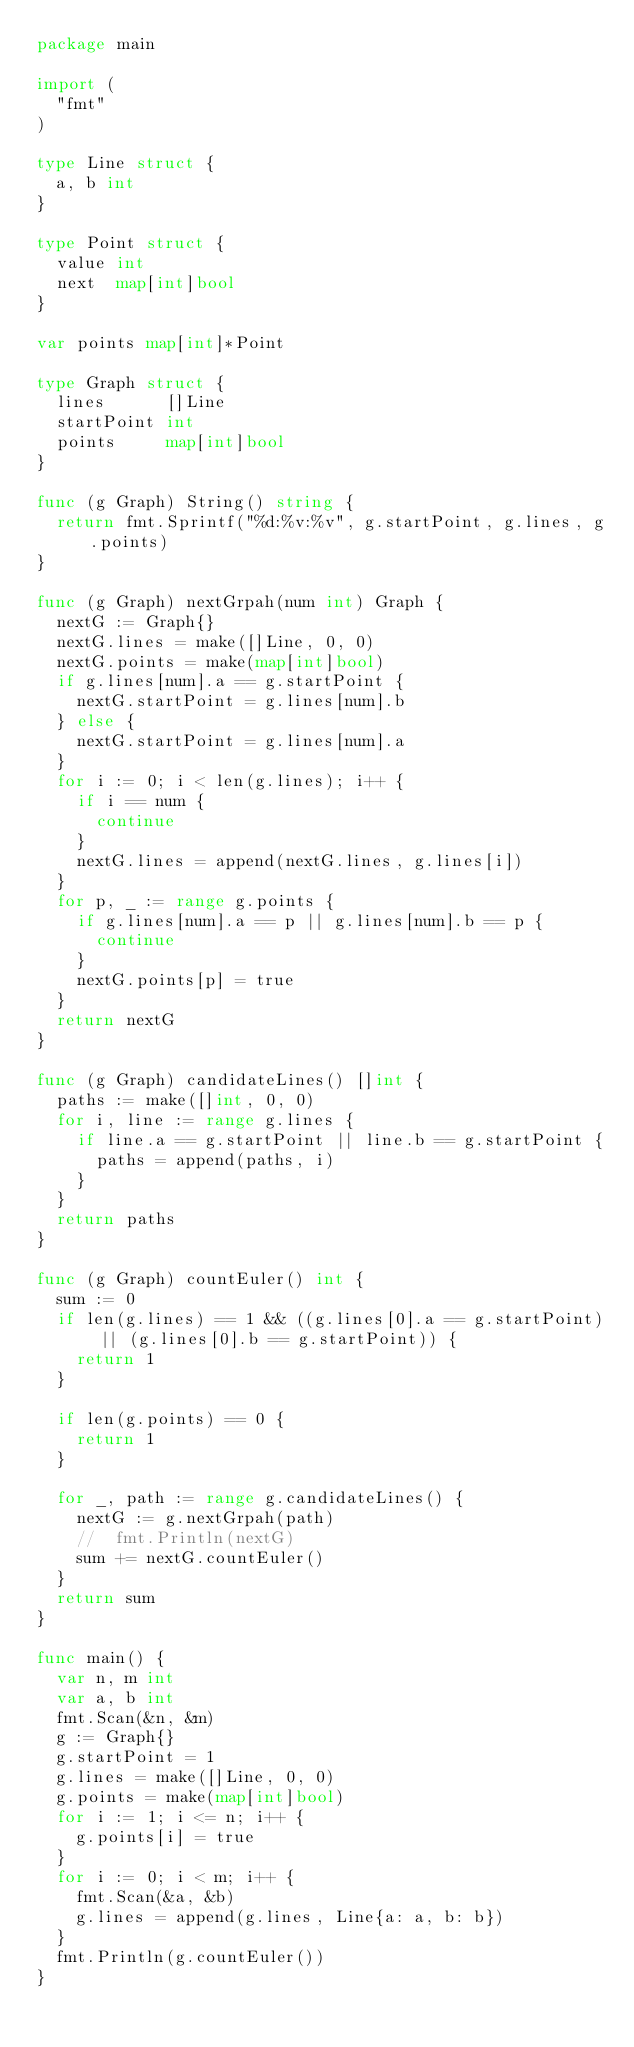<code> <loc_0><loc_0><loc_500><loc_500><_Go_>package main

import (
	"fmt"
)

type Line struct {
	a, b int
}

type Point struct {
	value int
	next  map[int]bool
}

var points map[int]*Point

type Graph struct {
	lines      []Line
	startPoint int
	points     map[int]bool
}

func (g Graph) String() string {
	return fmt.Sprintf("%d:%v:%v", g.startPoint, g.lines, g.points)
}

func (g Graph) nextGrpah(num int) Graph {
	nextG := Graph{}
	nextG.lines = make([]Line, 0, 0)
	nextG.points = make(map[int]bool)
	if g.lines[num].a == g.startPoint {
		nextG.startPoint = g.lines[num].b
	} else {
		nextG.startPoint = g.lines[num].a
	}
	for i := 0; i < len(g.lines); i++ {
		if i == num {
			continue
		}
		nextG.lines = append(nextG.lines, g.lines[i])
	}
	for p, _ := range g.points {
		if g.lines[num].a == p || g.lines[num].b == p {
			continue
		}
		nextG.points[p] = true
	}
	return nextG
}

func (g Graph) candidateLines() []int {
	paths := make([]int, 0, 0)
	for i, line := range g.lines {
		if line.a == g.startPoint || line.b == g.startPoint {
			paths = append(paths, i)
		}
	}
	return paths
}

func (g Graph) countEuler() int {
	sum := 0
	if len(g.lines) == 1 && ((g.lines[0].a == g.startPoint) || (g.lines[0].b == g.startPoint)) {
		return 1
	}

	if len(g.points) == 0 {
		return 1
	}

	for _, path := range g.candidateLines() {
		nextG := g.nextGrpah(path)
		//	fmt.Println(nextG)
		sum += nextG.countEuler()
	}
	return sum
}

func main() {
	var n, m int
	var a, b int
	fmt.Scan(&n, &m)
	g := Graph{}
	g.startPoint = 1
	g.lines = make([]Line, 0, 0)
	g.points = make(map[int]bool)
	for i := 1; i <= n; i++ {
		g.points[i] = true
	}
	for i := 0; i < m; i++ {
		fmt.Scan(&a, &b)
		g.lines = append(g.lines, Line{a: a, b: b})
	}
	fmt.Println(g.countEuler())
}</code> 